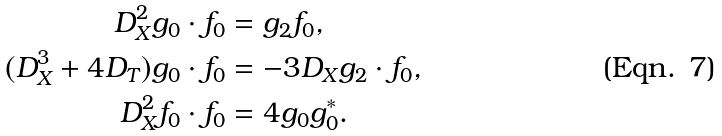Convert formula to latex. <formula><loc_0><loc_0><loc_500><loc_500>D _ { X } ^ { 2 } g _ { 0 } \cdot f _ { 0 } & = g _ { 2 } f _ { 0 } , \\ ( D _ { X } ^ { 3 } + 4 D _ { T } ) g _ { 0 } \cdot f _ { 0 } & = - 3 D _ { X } g _ { 2 } \cdot f _ { 0 } , \\ D _ { X } ^ { 2 } f _ { 0 } \cdot f _ { 0 } & = 4 g _ { 0 } g ^ { * } _ { 0 } .</formula> 